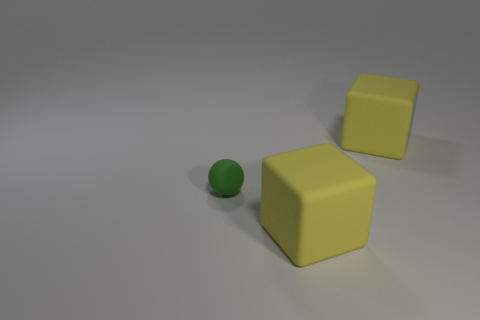Add 1 brown metal blocks. How many objects exist? 4 Subtract all cubes. How many objects are left? 1 Subtract 0 brown spheres. How many objects are left? 3 Subtract all rubber spheres. Subtract all large things. How many objects are left? 0 Add 2 tiny green objects. How many tiny green objects are left? 3 Add 3 cubes. How many cubes exist? 5 